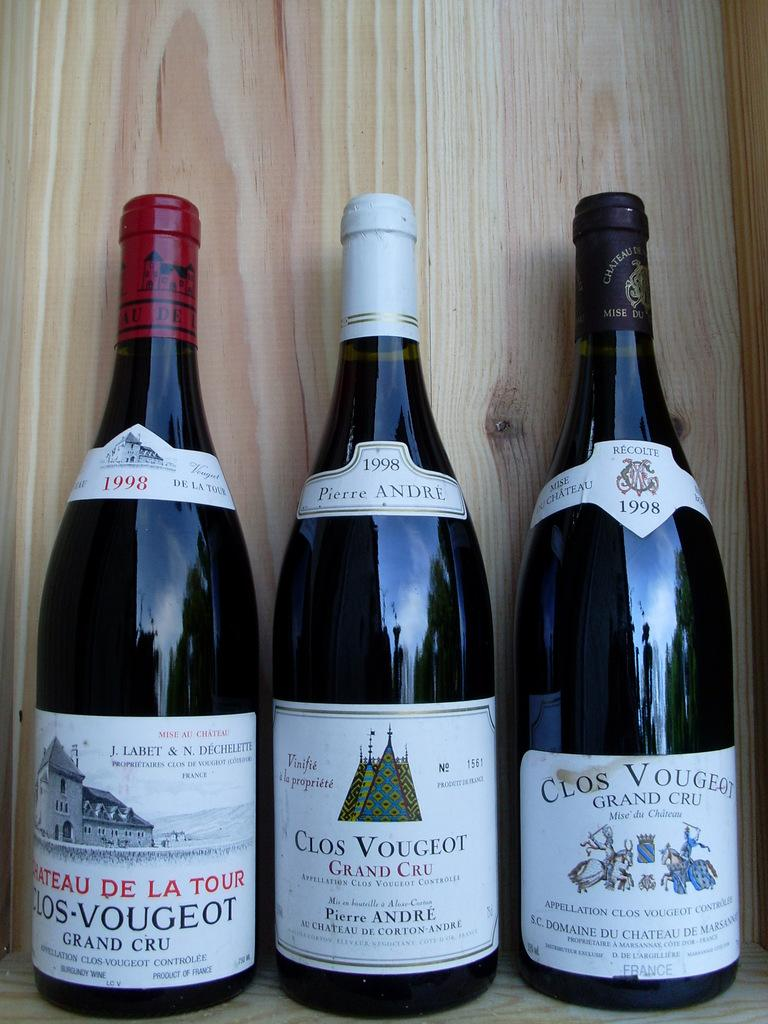<image>
Provide a brief description of the given image. Three different varieties of Clos Vougeot  wine bottles. 